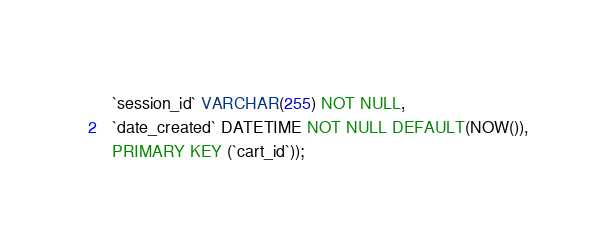Convert code to text. <code><loc_0><loc_0><loc_500><loc_500><_SQL_>  `session_id` VARCHAR(255) NOT NULL,
  `date_created` DATETIME NOT NULL DEFAULT(NOW()),
  PRIMARY KEY (`cart_id`));</code> 